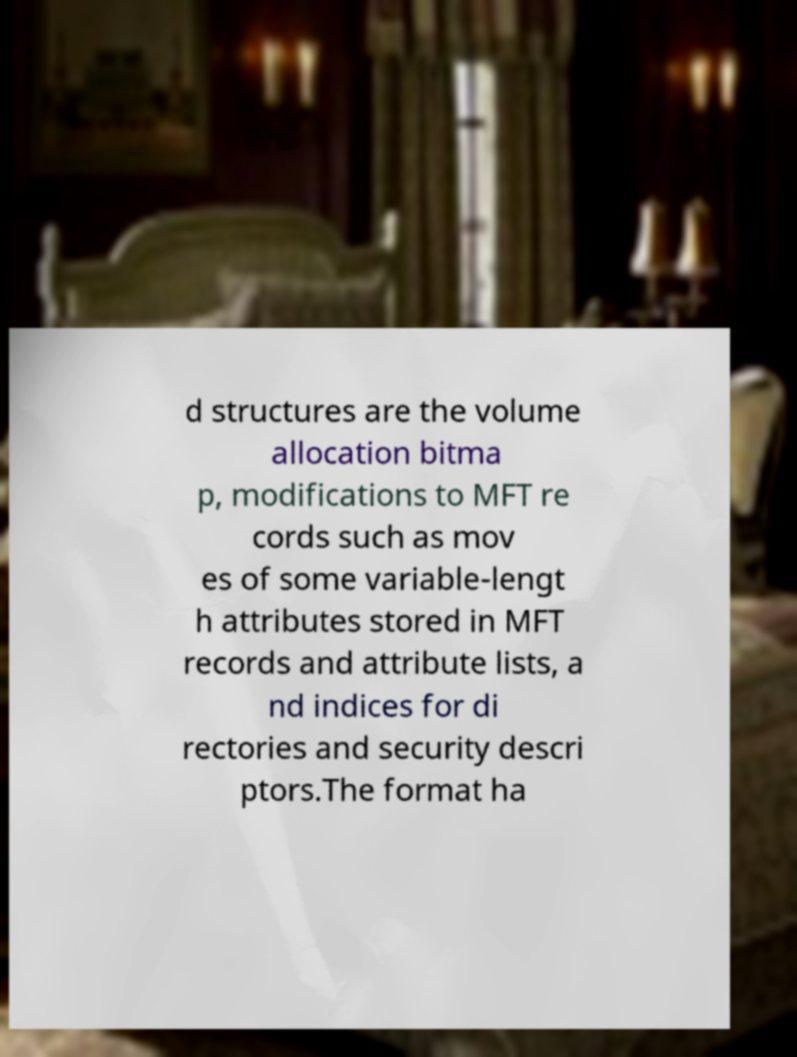Can you accurately transcribe the text from the provided image for me? d structures are the volume allocation bitma p, modifications to MFT re cords such as mov es of some variable-lengt h attributes stored in MFT records and attribute lists, a nd indices for di rectories and security descri ptors.The format ha 